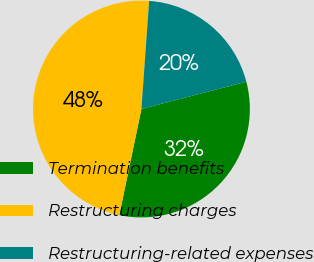Convert chart to OTSL. <chart><loc_0><loc_0><loc_500><loc_500><pie_chart><fcel>Termination benefits<fcel>Restructuring charges<fcel>Restructuring-related expenses<nl><fcel>32.33%<fcel>47.86%<fcel>19.81%<nl></chart> 